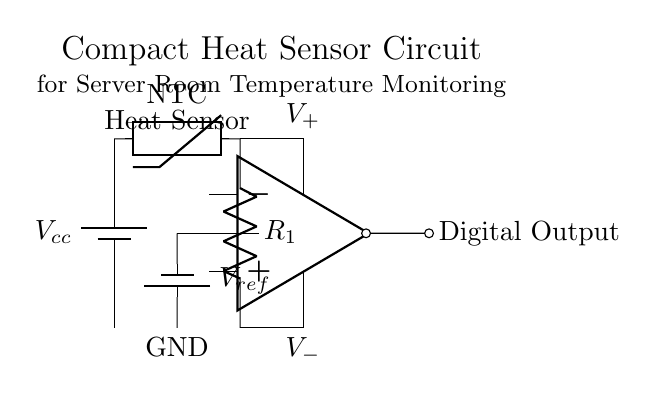What type of sensor is used in this circuit? The circuit uses a thermistor, which is indicated in the diagram as a component labeled "NTC". This type of sensor is sensitive to temperature changes.
Answer: thermistor What is the function of the comparator in this circuit? The comparator, represented by the operational amplifier, compares the voltage from the thermistor with a reference voltage. Its output signals whether the temperature exceeds a set threshold.
Answer: comparison What is the value of the reference voltage in this circuit? The reference voltage, labeled as "V_ref" in the diagram, does not have a specified numerical value in the provided information. It is necessary to define this voltage based on the desired temperature threshold for comparison.
Answer: unspecified What is the output type of this circuit? The output from the circuit is labeled as "Digital Output," meaning it provides a binary high or low signal based on the comparator's assessment of the temperature.
Answer: Digital Output How many resistors are present in the circuit? There is one resistor labeled as "R_1" connected to the thermistor. This resistor is part of the voltage divider network used for temperature measurement.
Answer: one What kind of connection is between the comparator output and the digital output? The connection is a short, indicated by the line connecting the output of the comparator directly to a point that indicates "Digital Output," meaning the signal is sent with no extra components in between.
Answer: short What is the role of the thermistor in this system? The thermistor acts as a temperature-dependent resistor that changes its resistance based on the surrounding temperature, thus allowing the circuit to sense temperature variations.
Answer: temperature sensor 